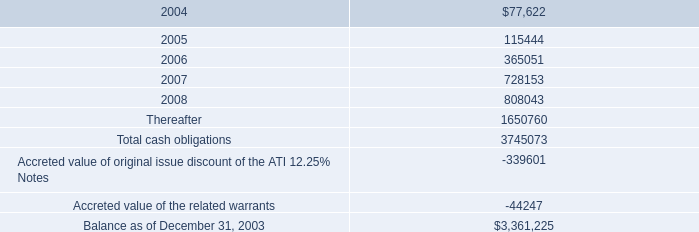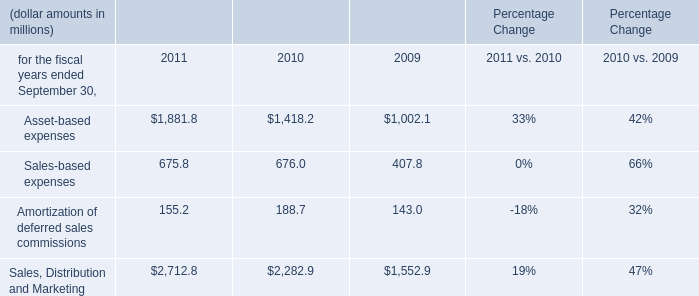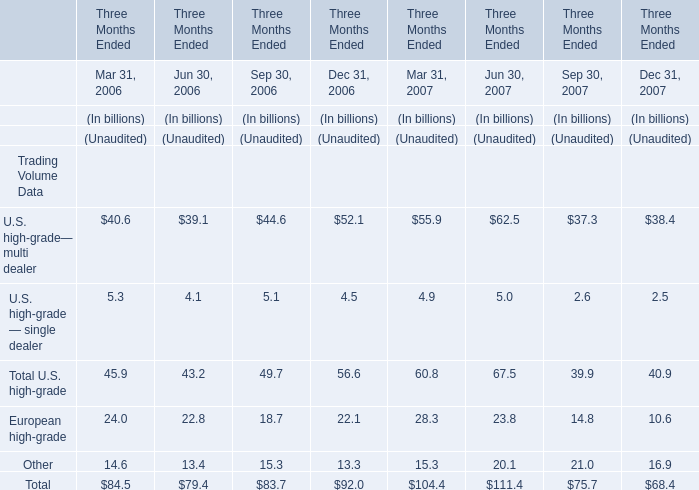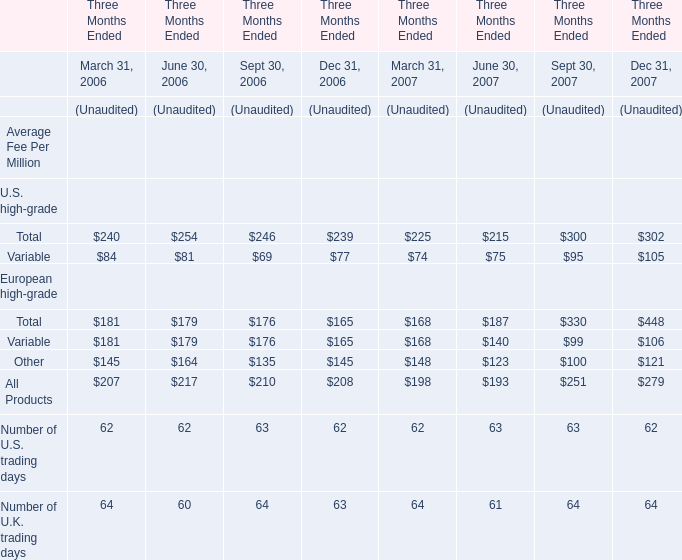during the year ended december 2003 what was the tax rate applicable to the recorded an unrealized loss 
Computations: ((0.3 - 0.2) / 0.3)
Answer: 0.33333. 